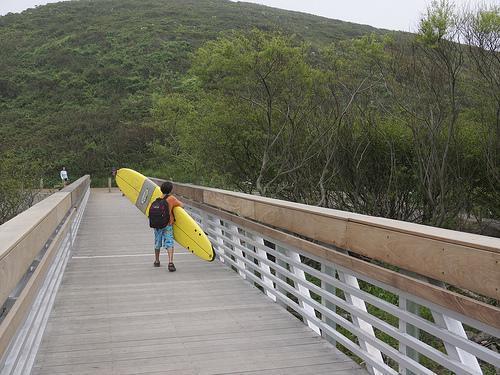How many surfboards?
Give a very brief answer. 1. 